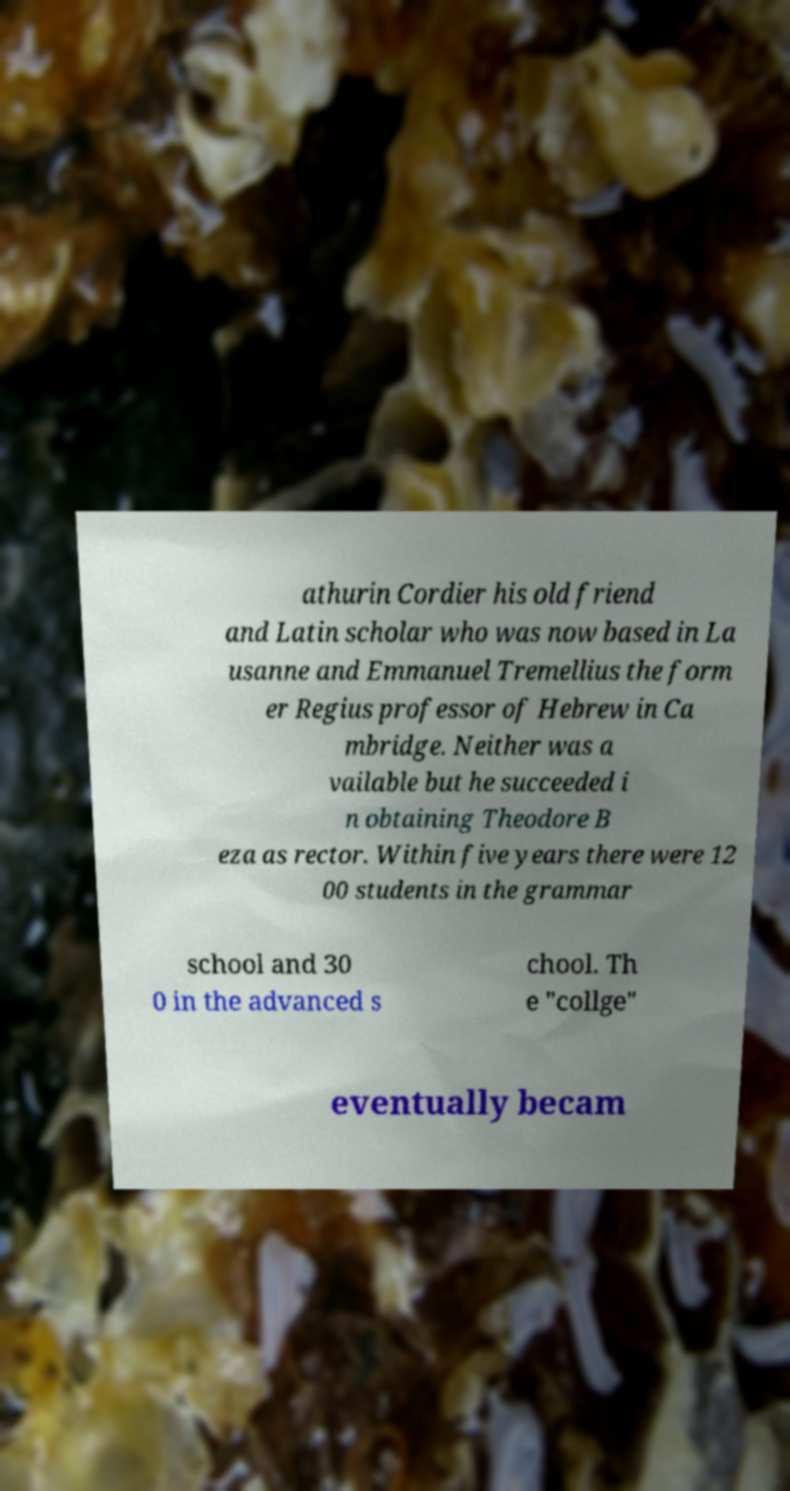For documentation purposes, I need the text within this image transcribed. Could you provide that? athurin Cordier his old friend and Latin scholar who was now based in La usanne and Emmanuel Tremellius the form er Regius professor of Hebrew in Ca mbridge. Neither was a vailable but he succeeded i n obtaining Theodore B eza as rector. Within five years there were 12 00 students in the grammar school and 30 0 in the advanced s chool. Th e "collge" eventually becam 